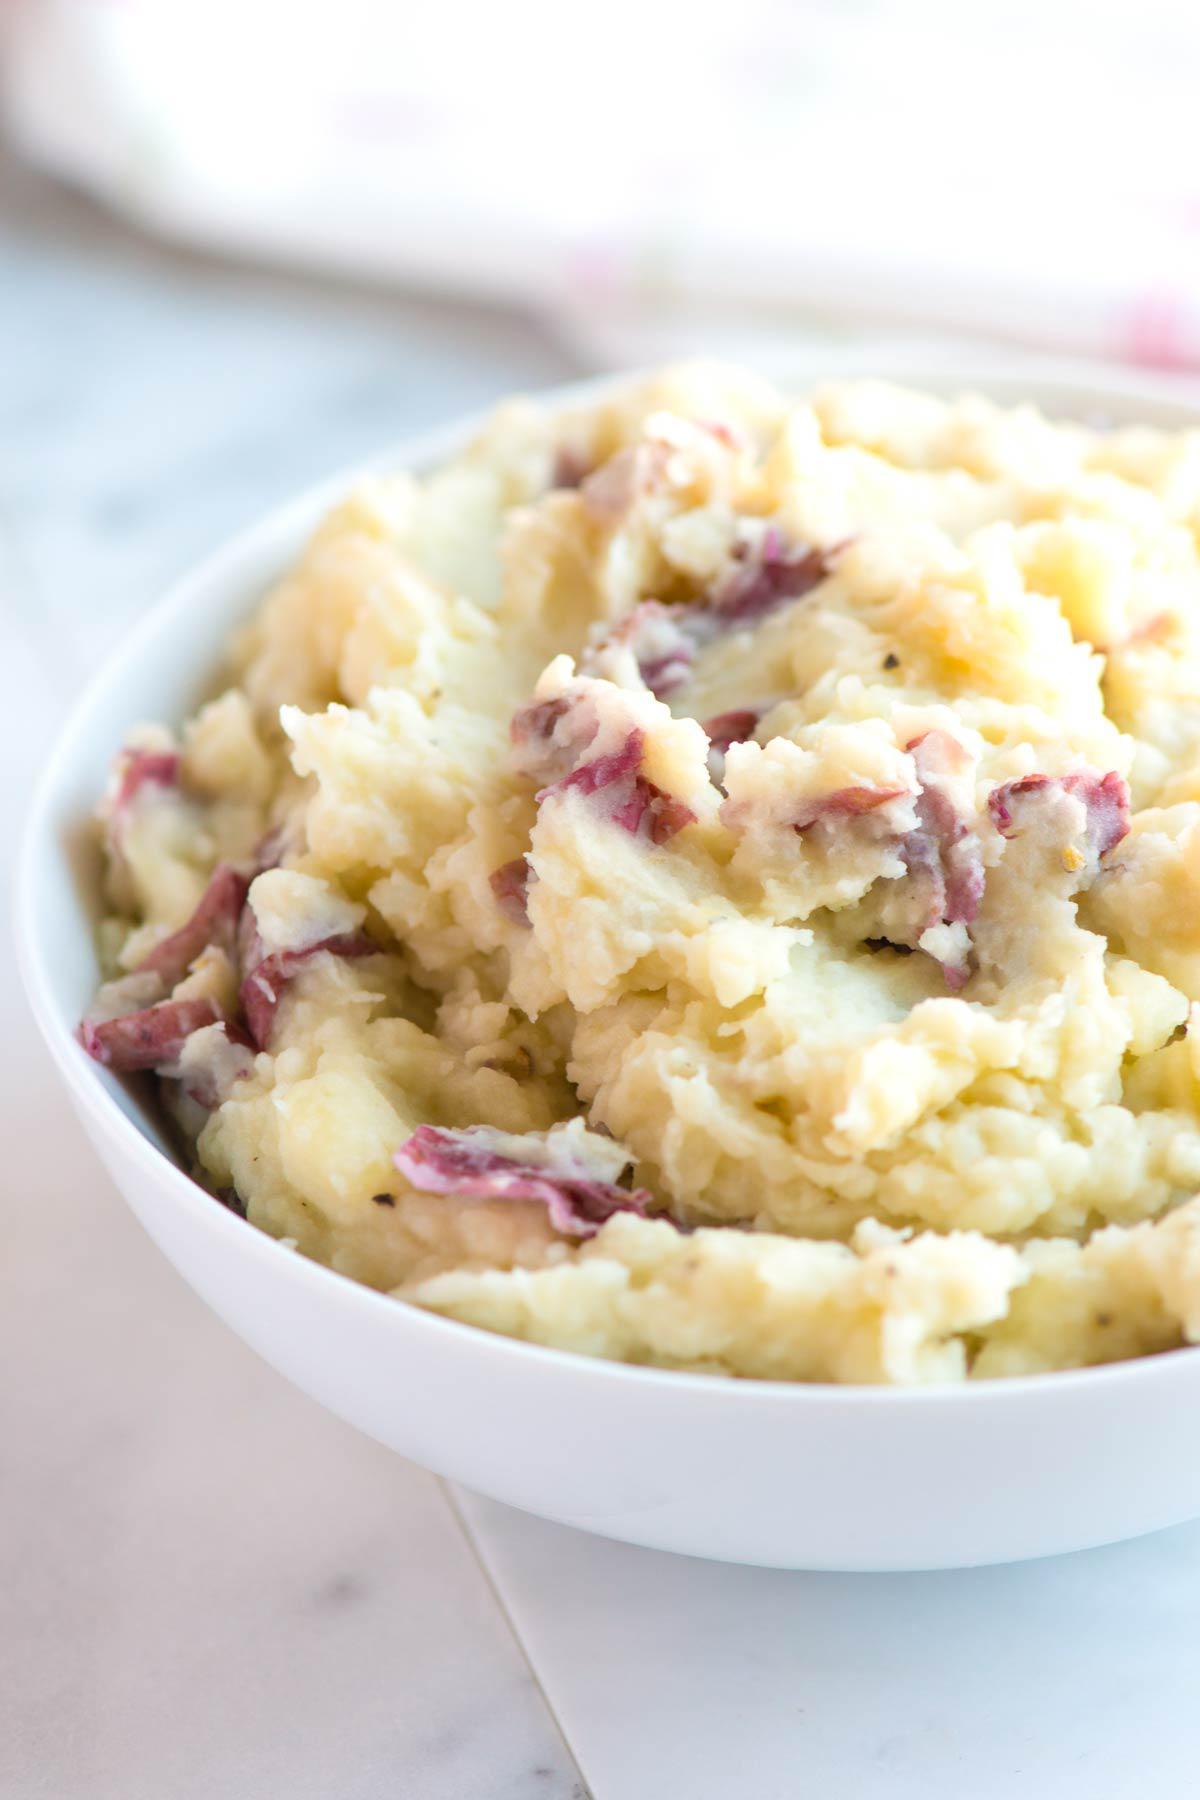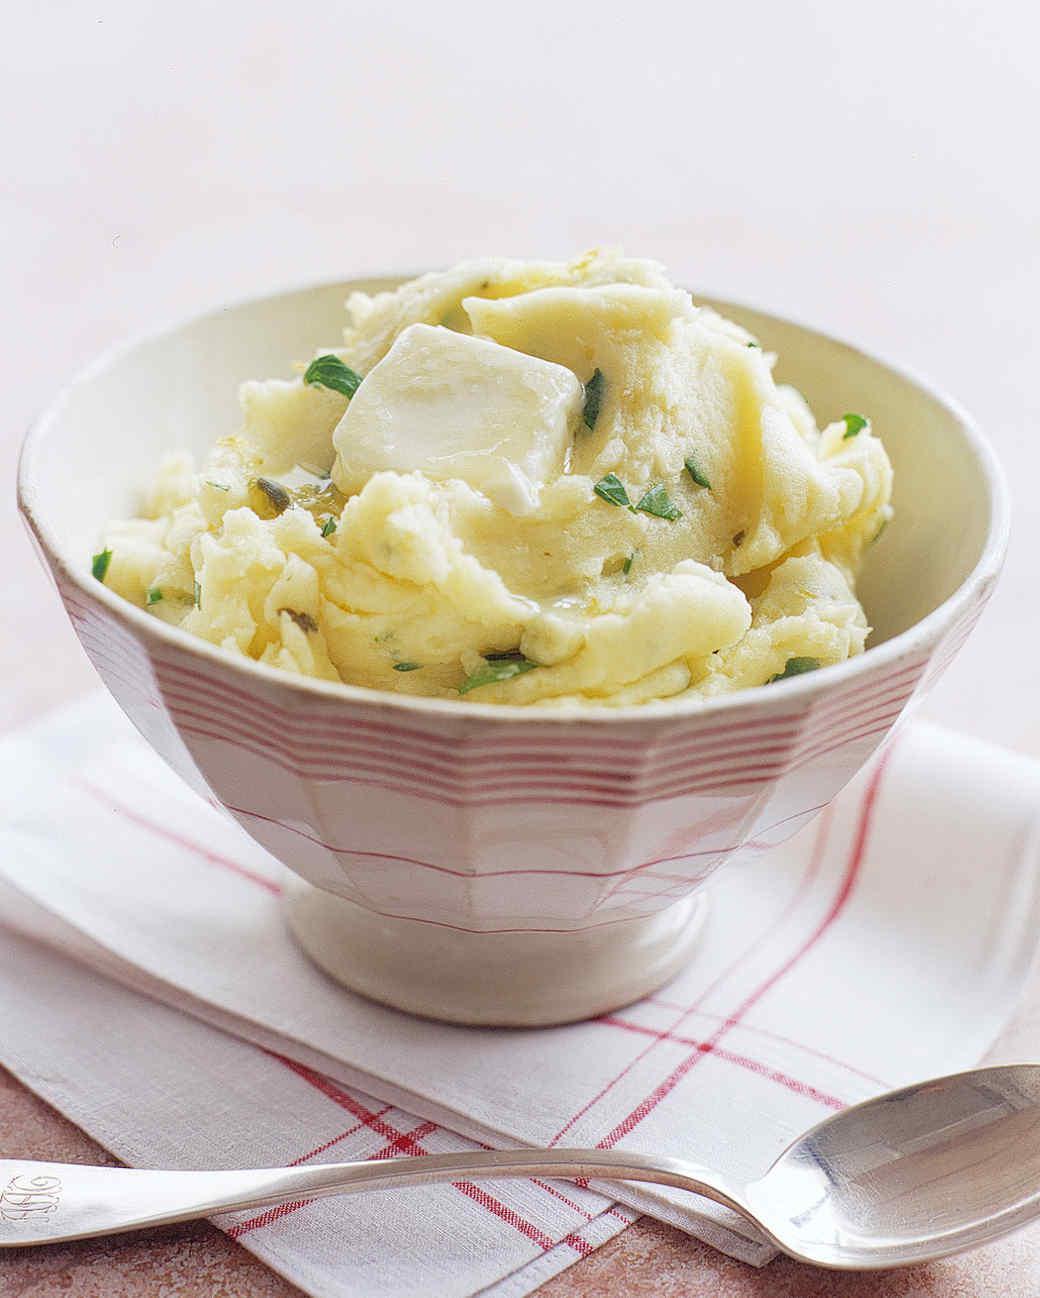The first image is the image on the left, the second image is the image on the right. Assess this claim about the two images: "There is one spoon sitting next to a bowl of food.". Correct or not? Answer yes or no. Yes. The first image is the image on the left, the second image is the image on the right. Given the left and right images, does the statement "an eating utensil can be seen in the image on the right" hold true? Answer yes or no. Yes. 